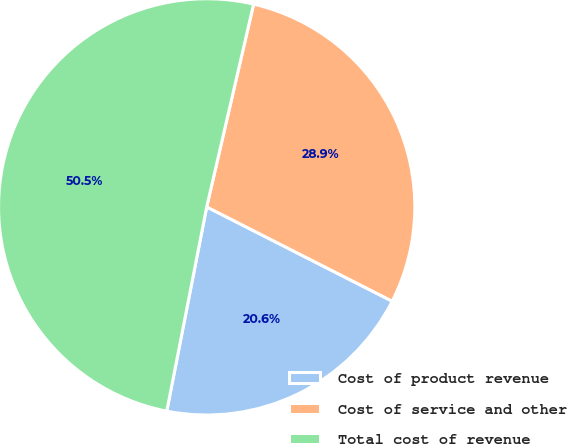Convert chart. <chart><loc_0><loc_0><loc_500><loc_500><pie_chart><fcel>Cost of product revenue<fcel>Cost of service and other<fcel>Total cost of revenue<nl><fcel>20.59%<fcel>28.87%<fcel>50.55%<nl></chart> 